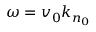Convert formula to latex. <formula><loc_0><loc_0><loc_500><loc_500>\omega = v _ { 0 } k _ { n _ { 0 } }</formula> 